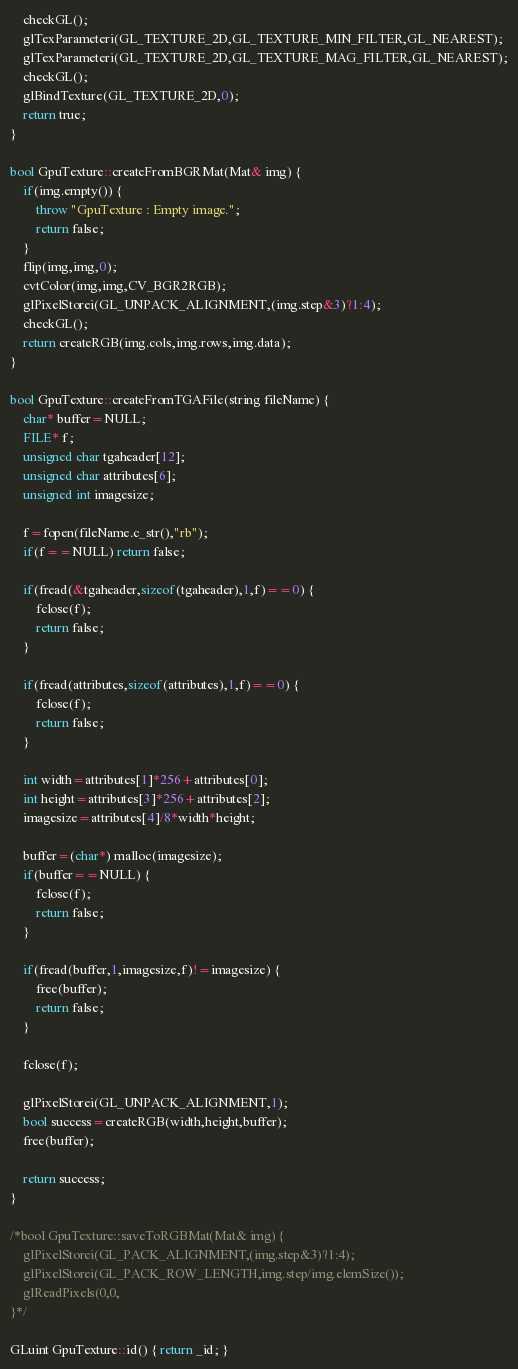Convert code to text. <code><loc_0><loc_0><loc_500><loc_500><_C++_>	checkGL();
	glTexParameteri(GL_TEXTURE_2D,GL_TEXTURE_MIN_FILTER,GL_NEAREST);
	glTexParameteri(GL_TEXTURE_2D,GL_TEXTURE_MAG_FILTER,GL_NEAREST);
	checkGL();
	glBindTexture(GL_TEXTURE_2D,0);
	return true;
}

bool GpuTexture::createFromBGRMat(Mat& img) {
	if(img.empty()) {
		throw "GpuTexture : Empty image.";
		return false;
	}
	flip(img,img,0);
	cvtColor(img,img,CV_BGR2RGB);
	glPixelStorei(GL_UNPACK_ALIGNMENT,(img.step&3)?1:4);
	checkGL();
	return createRGB(img.cols,img.rows,img.data);
}

bool GpuTexture::createFromTGAFile(string fileName) {
	char* buffer=NULL;
	FILE* f;
	unsigned char tgaheader[12];
	unsigned char attributes[6];
	unsigned int imagesize;

	f=fopen(fileName.c_str(),"rb");
	if(f==NULL) return false;

	if(fread(&tgaheader,sizeof(tgaheader),1,f)==0) {
		fclose(f);
		return false;
	}
	
	if(fread(attributes,sizeof(attributes),1,f)==0) {
		fclose(f);
		return false;
	}

	int width=attributes[1]*256+attributes[0];
	int height=attributes[3]*256+attributes[2];
	imagesize=attributes[4]/8*width*height;
	
	buffer=(char*) malloc(imagesize);
	if(buffer==NULL) {
		fclose(f);
		return false;
	}

	if(fread(buffer,1,imagesize,f)!=imagesize) {
		free(buffer);
		return false;
	}

	fclose(f);
	
	glPixelStorei(GL_UNPACK_ALIGNMENT,1);
	bool success=createRGB(width,height,buffer);
	free(buffer);
	
	return success;
}

/*bool GpuTexture::saveToRGBMat(Mat& img) {
	glPixelStorei(GL_PACK_ALIGNMENT,(img.step&3)?1:4);
	glPixelStorei(GL_PACK_ROW_LENGTH,img.step/img.elemSize());
	glReadPixels(0,0,
}*/

GLuint GpuTexture::id() { return _id; }</code> 